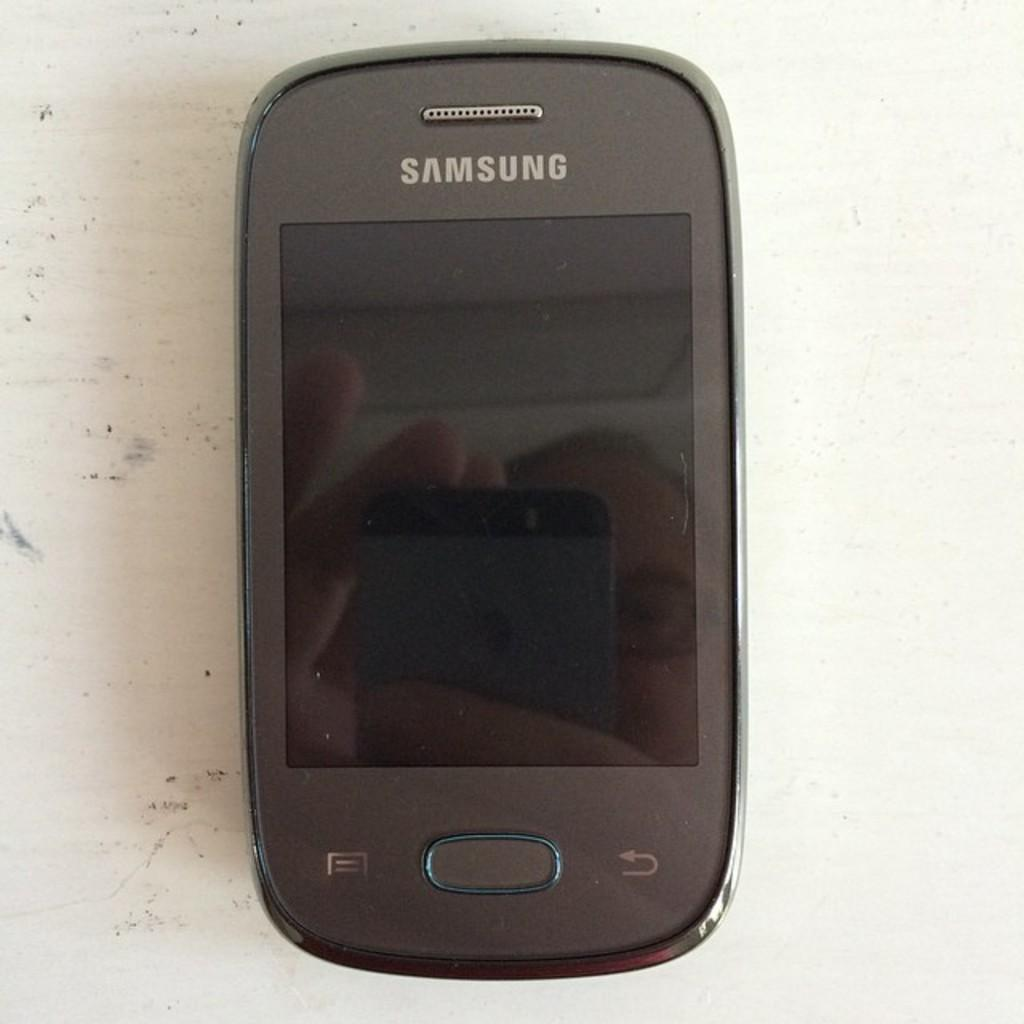<image>
Provide a brief description of the given image. Old cellphone with the brand "Samsung" on it. 